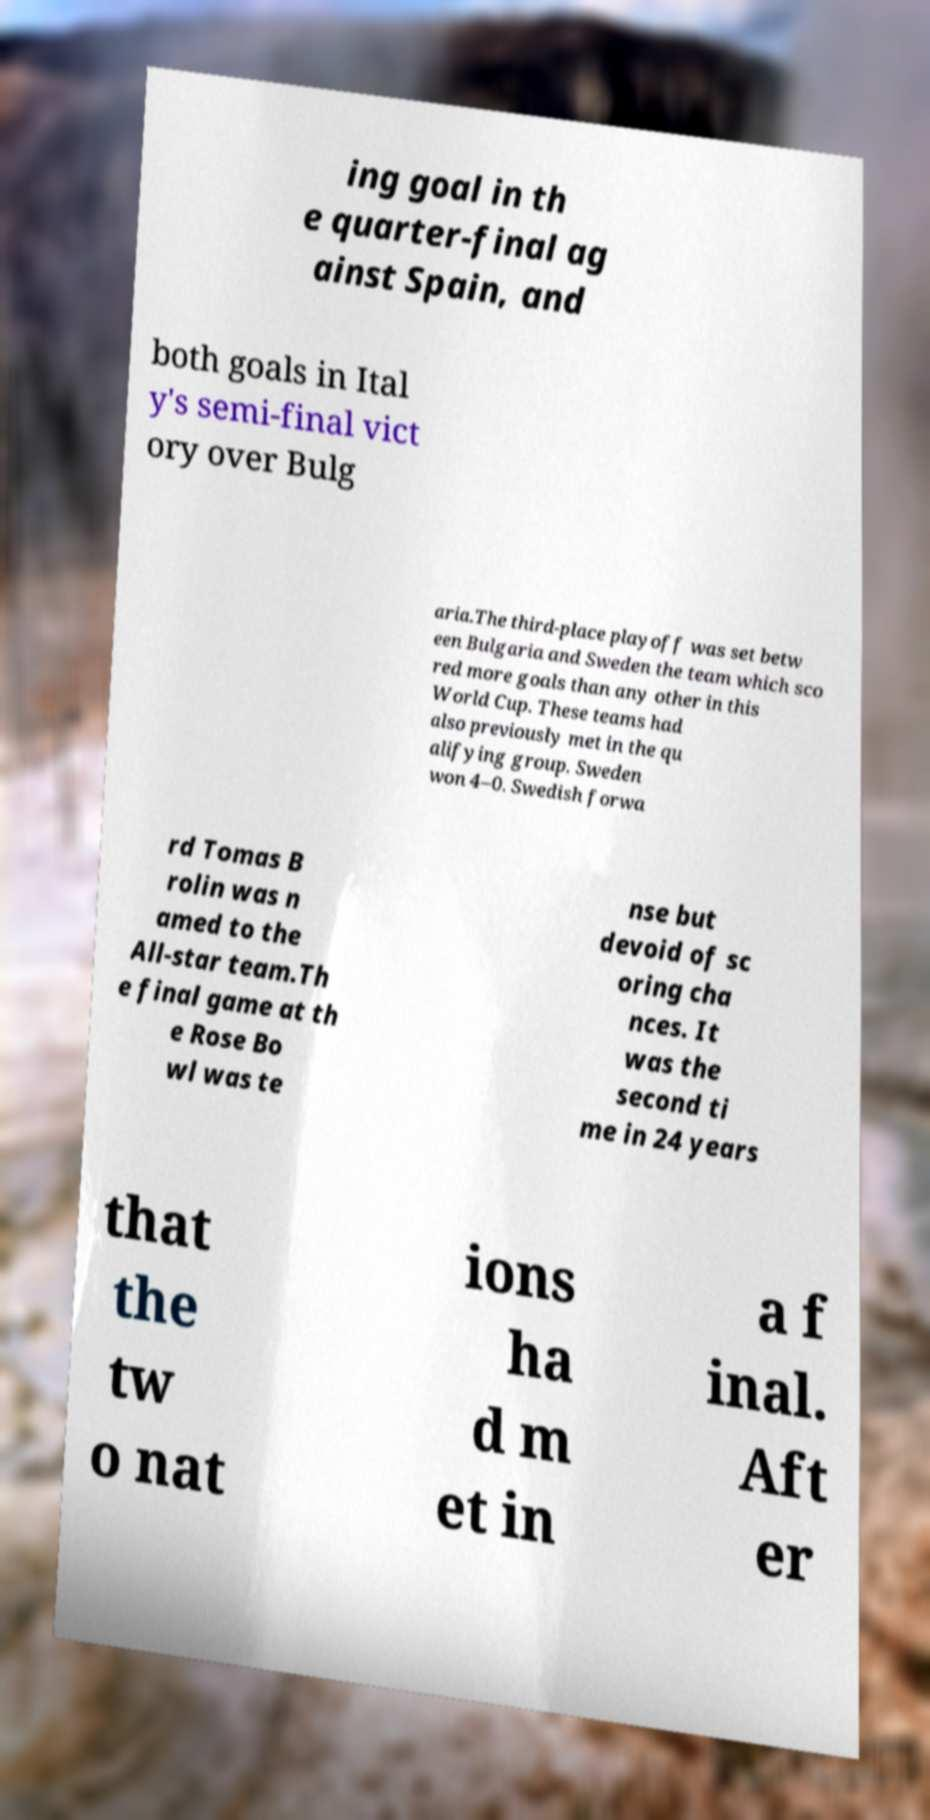Please read and relay the text visible in this image. What does it say? ing goal in th e quarter-final ag ainst Spain, and both goals in Ital y's semi-final vict ory over Bulg aria.The third-place playoff was set betw een Bulgaria and Sweden the team which sco red more goals than any other in this World Cup. These teams had also previously met in the qu alifying group. Sweden won 4–0. Swedish forwa rd Tomas B rolin was n amed to the All-star team.Th e final game at th e Rose Bo wl was te nse but devoid of sc oring cha nces. It was the second ti me in 24 years that the tw o nat ions ha d m et in a f inal. Aft er 